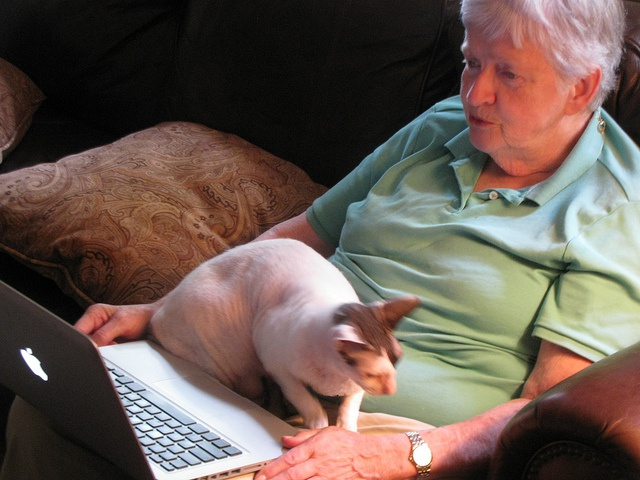Describe the objects in this image and their specific colors. I can see people in black, darkgray, gray, and lightpink tones, couch in black, gray, maroon, and brown tones, cat in black, gray, lightgray, brown, and darkgray tones, laptop in black, lavender, gray, and lightblue tones, and couch in black, maroon, gray, and brown tones in this image. 